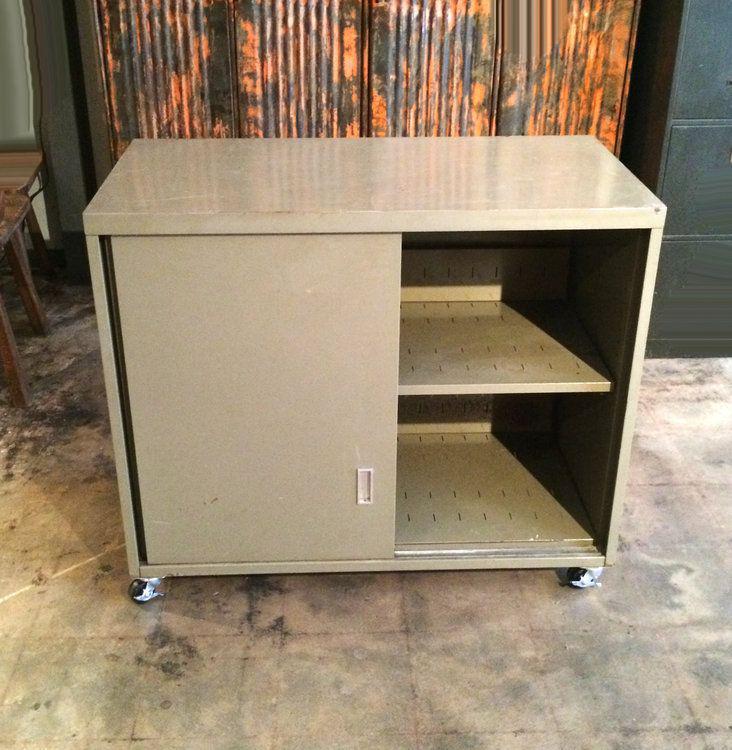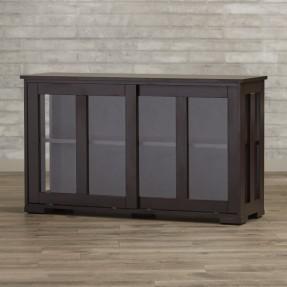The first image is the image on the left, the second image is the image on the right. Given the left and right images, does the statement "In 1 of the images, 1 cabinet on a solid floor has a door opened in the front." hold true? Answer yes or no. Yes. The first image is the image on the left, the second image is the image on the right. Evaluate the accuracy of this statement regarding the images: "Two low, wide wooden shelving units are different colors and different designs.". Is it true? Answer yes or no. No. 